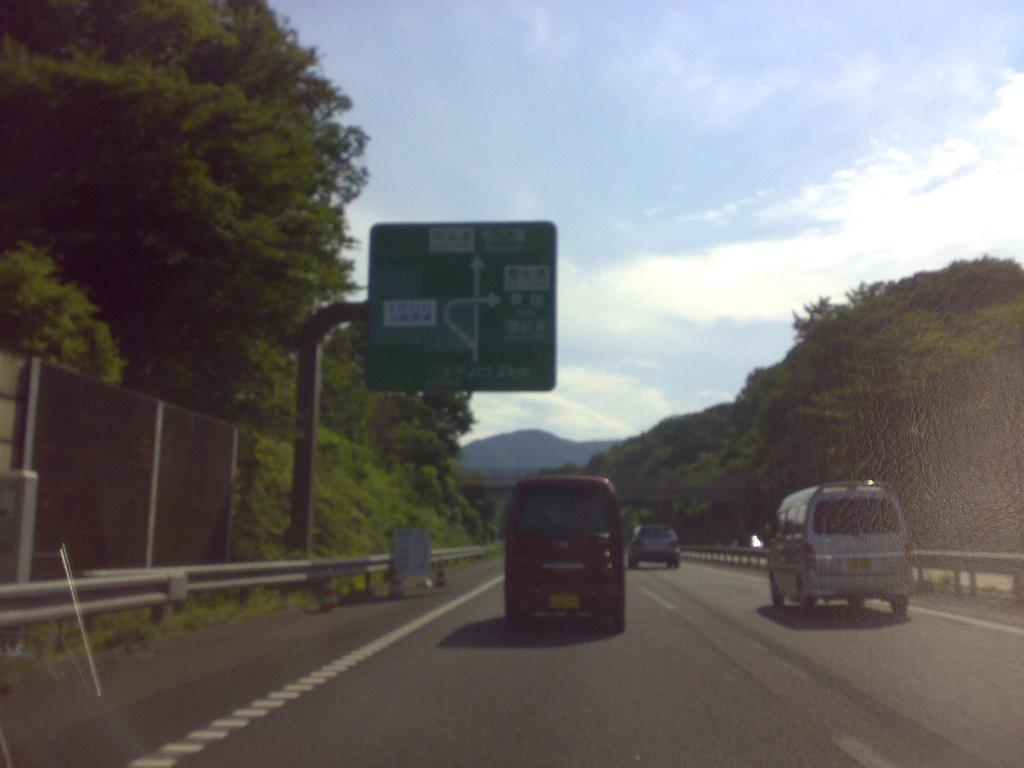What is the main feature of the image? There is a road in the image. What can be seen on the road? There are vehicles on the road. What surrounds the road? There is fencing and trees on both sides of the road. What is visible in the background of the image? There are mountains in the background of the image. What part of the natural environment is visible in the image? The sky is visible in the image. What type of story is being told by the knife in the image? There is no knife present in the image, so no story can be told by a knife. 